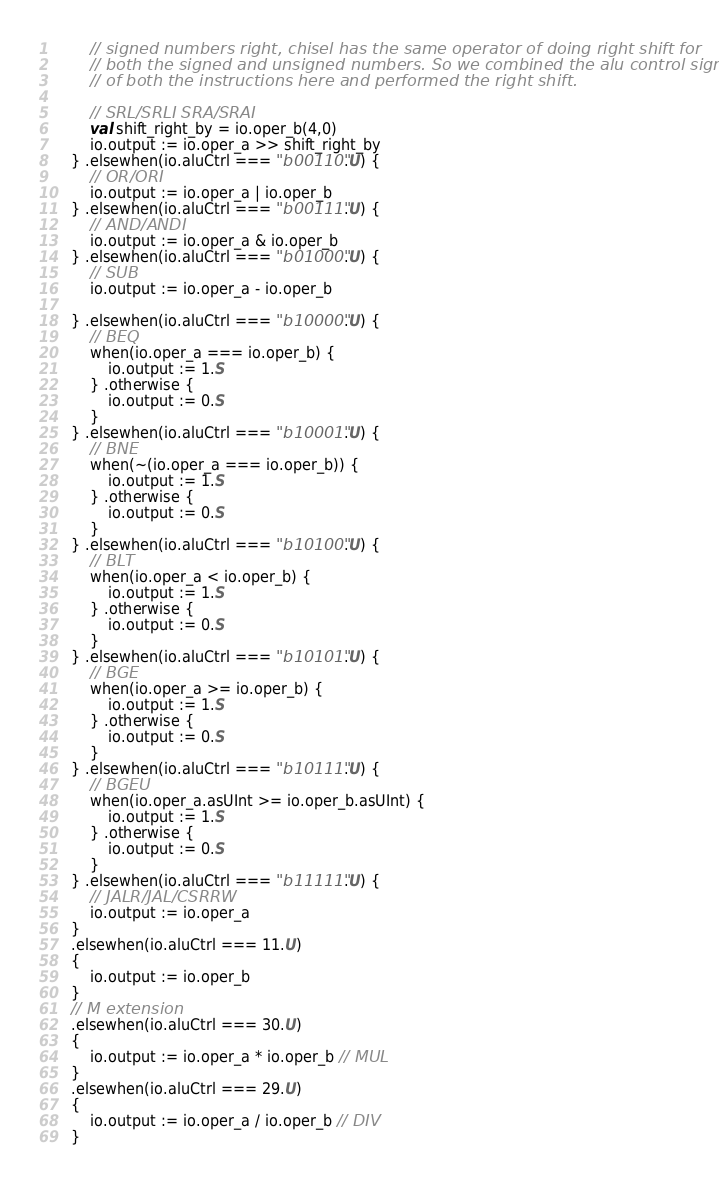<code> <loc_0><loc_0><loc_500><loc_500><_Scala_>        // signed numbers right, chisel has the same operator of doing right shift for
        // both the signed and unsigned numbers. So we combined the alu control signals
        // of both the instructions here and performed the right shift.

        // SRL/SRLI SRA/SRAI
        val shift_right_by = io.oper_b(4,0)
        io.output := io.oper_a >> shift_right_by
    } .elsewhen(io.aluCtrl === "b00110".U) {
        // OR/ORI
        io.output := io.oper_a | io.oper_b
    } .elsewhen(io.aluCtrl === "b00111".U) {
        // AND/ANDI
        io.output := io.oper_a & io.oper_b
    } .elsewhen(io.aluCtrl === "b01000".U) {
        // SUB
        io.output := io.oper_a - io.oper_b
    
    } .elsewhen(io.aluCtrl === "b10000".U) {
        // BEQ
        when(io.oper_a === io.oper_b) {
            io.output := 1.S
        } .otherwise {
            io.output := 0.S
        }
    } .elsewhen(io.aluCtrl === "b10001".U) {
        // BNE
        when(~(io.oper_a === io.oper_b)) {
            io.output := 1.S
        } .otherwise {
            io.output := 0.S
        }
    } .elsewhen(io.aluCtrl === "b10100".U) {
        // BLT
        when(io.oper_a < io.oper_b) {
            io.output := 1.S
        } .otherwise {
            io.output := 0.S
        }
    } .elsewhen(io.aluCtrl === "b10101".U) {
        // BGE
        when(io.oper_a >= io.oper_b) {
            io.output := 1.S
        } .otherwise {
            io.output := 0.S
        }
    } .elsewhen(io.aluCtrl === "b10111".U) {
        // BGEU
        when(io.oper_a.asUInt >= io.oper_b.asUInt) {
            io.output := 1.S
        } .otherwise {
            io.output := 0.S
        }
    } .elsewhen(io.aluCtrl === "b11111".U) {
        // JALR/JAL/CSRRW
        io.output := io.oper_a
    }
    .elsewhen(io.aluCtrl === 11.U)
    {
        io.output := io.oper_b
    }
    // M extension
    .elsewhen(io.aluCtrl === 30.U)
    {
        io.output := io.oper_a * io.oper_b // MUL
    }
    .elsewhen(io.aluCtrl === 29.U)
    {
        io.output := io.oper_a / io.oper_b // DIV
    }</code> 